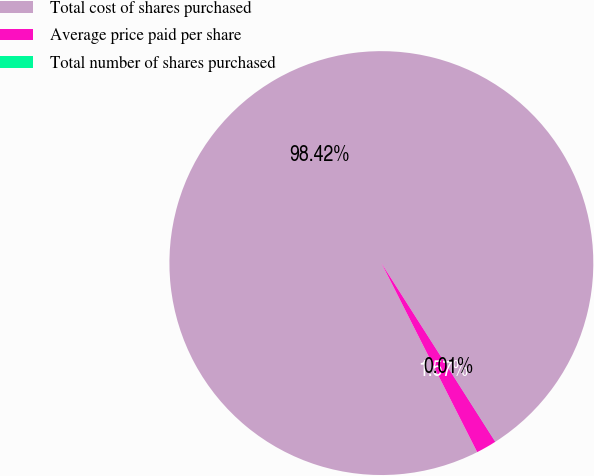Convert chart to OTSL. <chart><loc_0><loc_0><loc_500><loc_500><pie_chart><fcel>Total cost of shares purchased<fcel>Average price paid per share<fcel>Total number of shares purchased<nl><fcel>98.43%<fcel>1.57%<fcel>0.01%<nl></chart> 